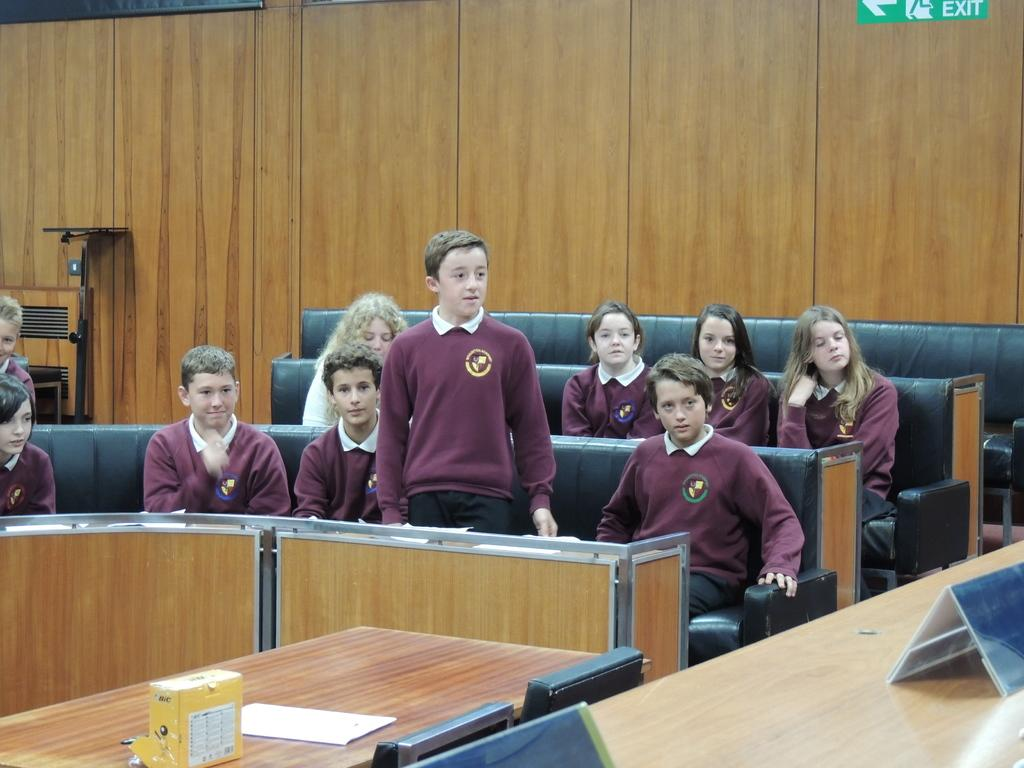What is the main subject of the image? The main subject of the image is a group of people. Where are the people located in the image? The people are sitting in the center of the image. What can be seen on the right side of the image? There is a table on the right side of the image. How does the stranger wash their hands in the image? There is no stranger present in the image, so it is not possible to determine how they might wash their hands. 